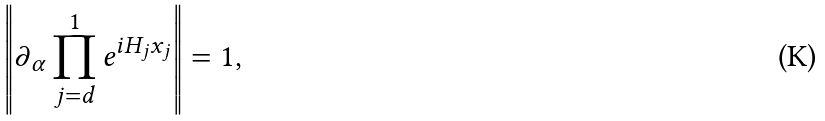Convert formula to latex. <formula><loc_0><loc_0><loc_500><loc_500>\left \| \partial _ { \alpha } \prod _ { j = d } ^ { 1 } e ^ { i H _ { j } x _ { j } } \right \| = 1 ,</formula> 